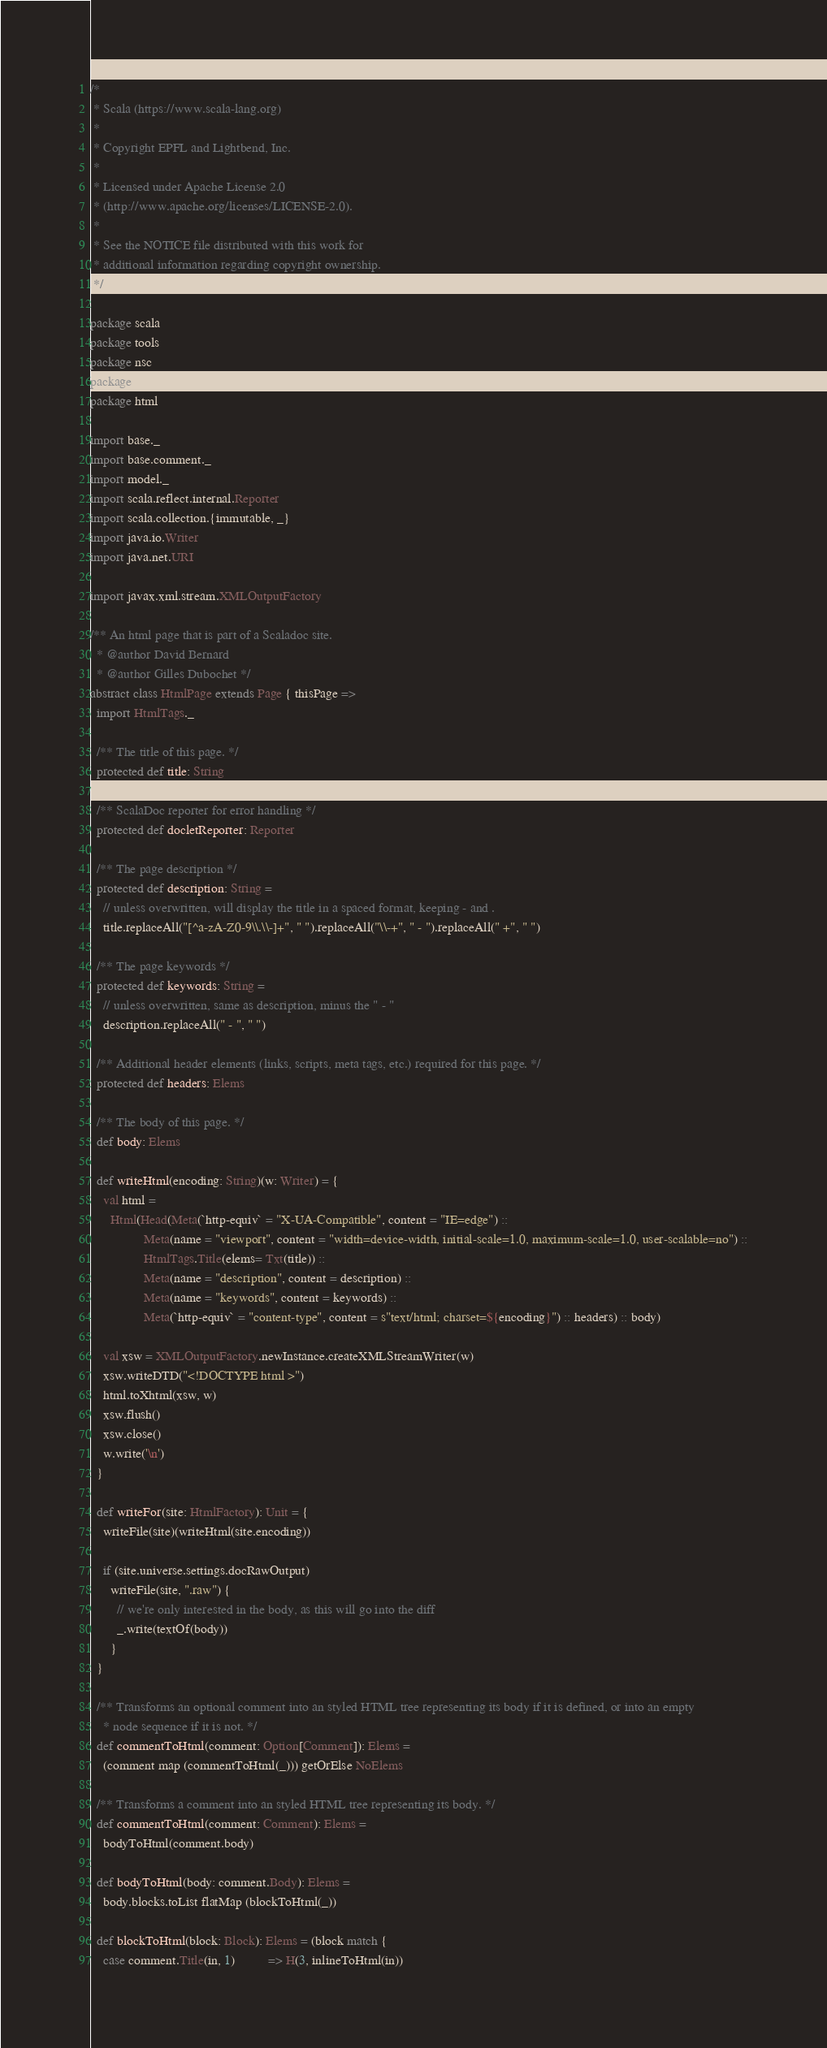<code> <loc_0><loc_0><loc_500><loc_500><_Scala_>/*
 * Scala (https://www.scala-lang.org)
 *
 * Copyright EPFL and Lightbend, Inc.
 *
 * Licensed under Apache License 2.0
 * (http://www.apache.org/licenses/LICENSE-2.0).
 *
 * See the NOTICE file distributed with this work for
 * additional information regarding copyright ownership.
 */

package scala
package tools
package nsc
package doc
package html

import base._
import base.comment._
import model._
import scala.reflect.internal.Reporter
import scala.collection.{immutable, _}
import java.io.Writer
import java.net.URI

import javax.xml.stream.XMLOutputFactory

/** An html page that is part of a Scaladoc site.
  * @author David Bernard
  * @author Gilles Dubochet */
abstract class HtmlPage extends Page { thisPage =>
  import HtmlTags._

  /** The title of this page. */
  protected def title: String

  /** ScalaDoc reporter for error handling */
  protected def docletReporter: Reporter

  /** The page description */
  protected def description: String =
    // unless overwritten, will display the title in a spaced format, keeping - and .
    title.replaceAll("[^a-zA-Z0-9\\.\\-]+", " ").replaceAll("\\-+", " - ").replaceAll(" +", " ")

  /** The page keywords */
  protected def keywords: String =
    // unless overwritten, same as description, minus the " - "
    description.replaceAll(" - ", " ")

  /** Additional header elements (links, scripts, meta tags, etc.) required for this page. */
  protected def headers: Elems

  /** The body of this page. */
  def body: Elems

  def writeHtml(encoding: String)(w: Writer) = {
    val html =
      Html(Head(Meta(`http-equiv` = "X-UA-Compatible", content = "IE=edge") ::
                Meta(name = "viewport", content = "width=device-width, initial-scale=1.0, maximum-scale=1.0, user-scalable=no") ::
                HtmlTags.Title(elems= Txt(title)) ::
                Meta(name = "description", content = description) ::
                Meta(name = "keywords", content = keywords) ::
                Meta(`http-equiv` = "content-type", content = s"text/html; charset=${encoding}") :: headers) :: body)

    val xsw = XMLOutputFactory.newInstance.createXMLStreamWriter(w)
    xsw.writeDTD("<!DOCTYPE html >")
    html.toXhtml(xsw, w)
    xsw.flush()
    xsw.close()
    w.write('\n')
  }

  def writeFor(site: HtmlFactory): Unit = {
    writeFile(site)(writeHtml(site.encoding))

    if (site.universe.settings.docRawOutput)
      writeFile(site, ".raw") {
        // we're only interested in the body, as this will go into the diff
        _.write(textOf(body))
      }
  }

  /** Transforms an optional comment into an styled HTML tree representing its body if it is defined, or into an empty
    * node sequence if it is not. */
  def commentToHtml(comment: Option[Comment]): Elems =
    (comment map (commentToHtml(_))) getOrElse NoElems

  /** Transforms a comment into an styled HTML tree representing its body. */
  def commentToHtml(comment: Comment): Elems =
    bodyToHtml(comment.body)

  def bodyToHtml(body: comment.Body): Elems =
    body.blocks.toList flatMap (blockToHtml(_))

  def blockToHtml(block: Block): Elems = (block match {
    case comment.Title(in, 1)          => H(3, inlineToHtml(in))</code> 